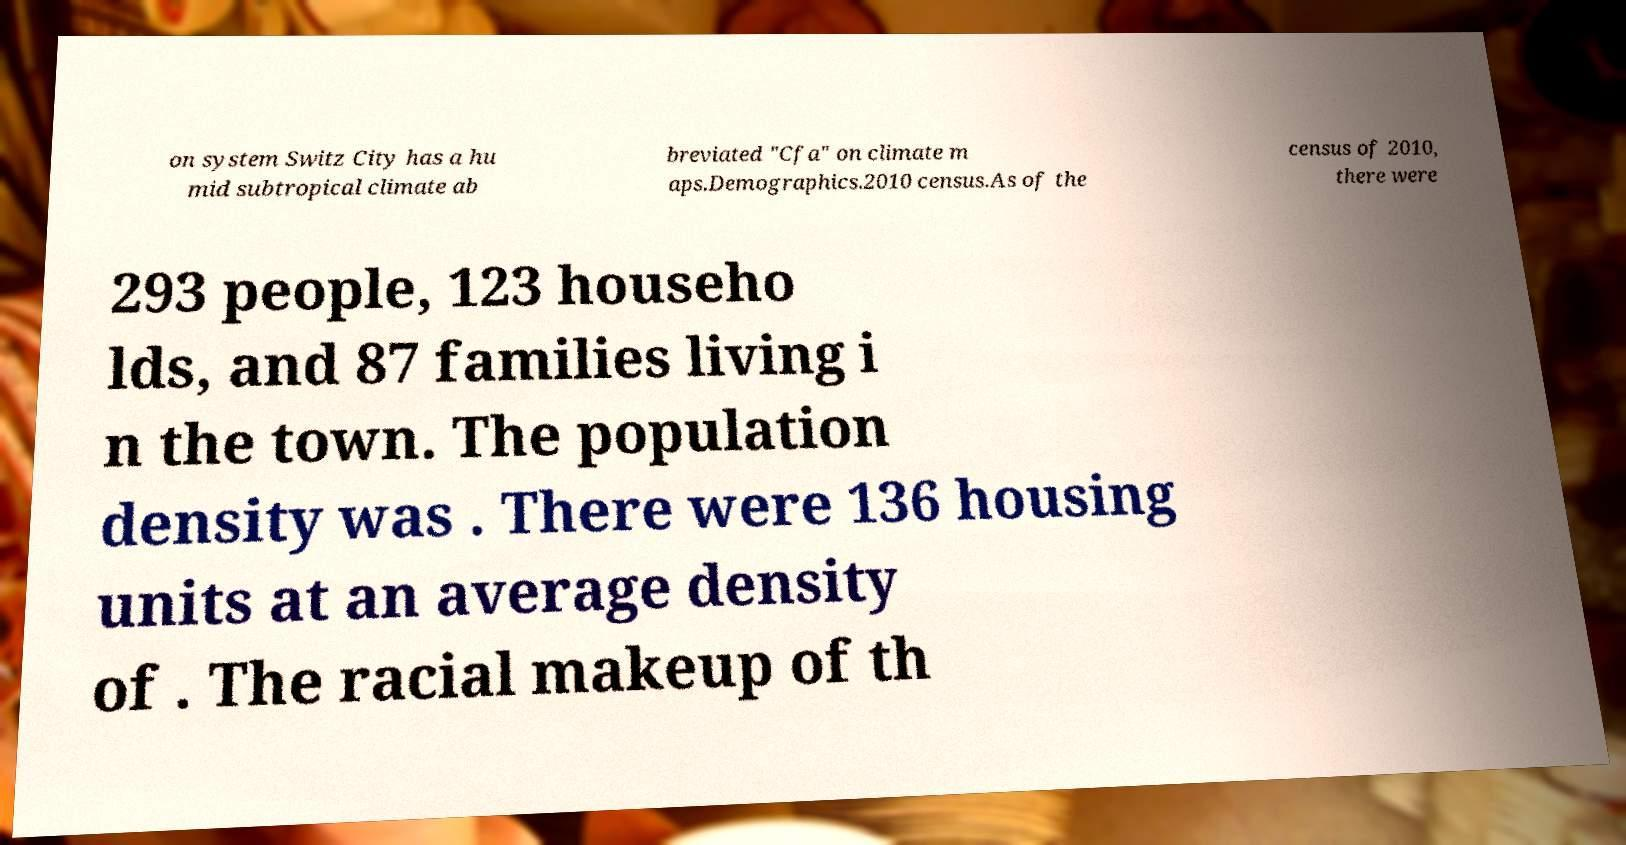Please identify and transcribe the text found in this image. on system Switz City has a hu mid subtropical climate ab breviated "Cfa" on climate m aps.Demographics.2010 census.As of the census of 2010, there were 293 people, 123 househo lds, and 87 families living i n the town. The population density was . There were 136 housing units at an average density of . The racial makeup of th 